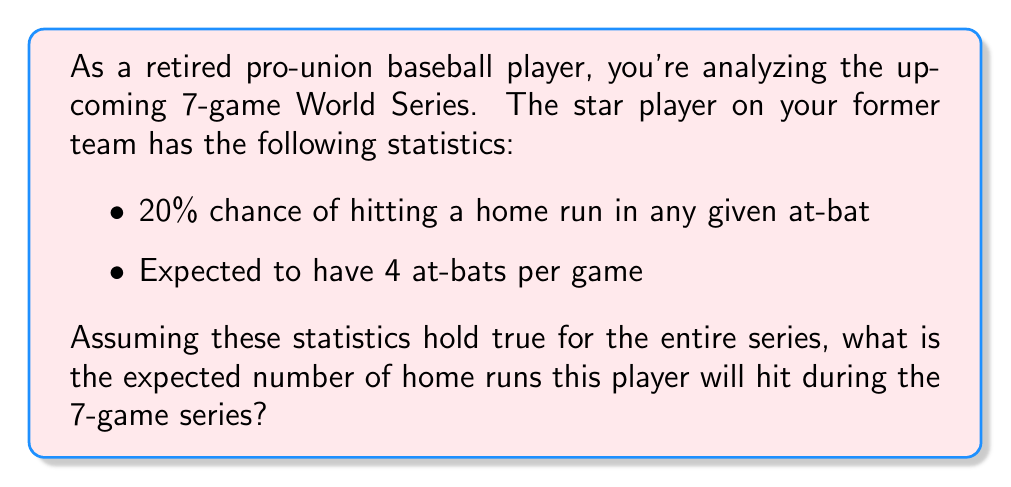Solve this math problem. Let's approach this step-by-step:

1) First, we need to calculate the expected number of home runs per game:
   - Probability of a home run per at-bat: $p = 0.20$
   - Number of at-bats per game: $n = 4$
   - Expected home runs per game: $E(\text{HR per game}) = n \times p = 4 \times 0.20 = 0.8$

2) Now, we need to extend this to the entire 7-game series:
   - Number of games in the series: $g = 7$
   - Expected home runs for the series: $E(\text{HR for series}) = E(\text{HR per game}) \times g$

3) Substituting the values:
   $E(\text{HR for series}) = 0.8 \times 7 = 5.6$

This calculation uses the linearity of expectation, where the expected value of a sum is the sum of the expected values. In this case, we're summing the expected home runs across all games in the series.
Answer: 5.6 home runs 